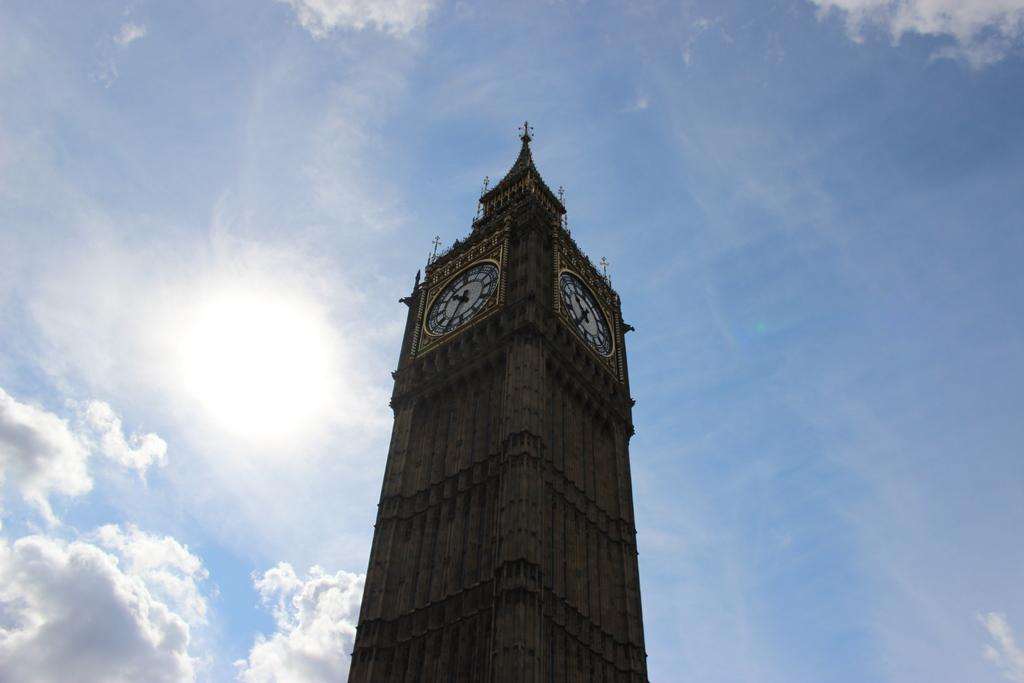What is the main structure in the image? There is a tower in the image. What feature is present on the tower? The tower has clocks on it. What can be seen in the background of the image? Sky is visible in the background of the image. What is the weather condition in the image? Clouds are present in the sky, indicating a partly cloudy day. What type of expert can be seen giving a lecture in the image? There is no expert or lecture present in the image; it features a tower with clocks and a sky with clouds. 